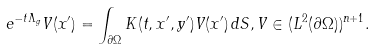Convert formula to latex. <formula><loc_0><loc_0><loc_500><loc_500>e ^ { - t \Lambda _ { g } } V ( x ^ { \prime } ) = \int _ { \partial \Omega } K ( t , x ^ { \prime } , y ^ { \prime } ) V ( x ^ { \prime } ) \, d S , V \in ( L ^ { 2 } ( \partial \Omega ) ) ^ { n + 1 } .</formula> 